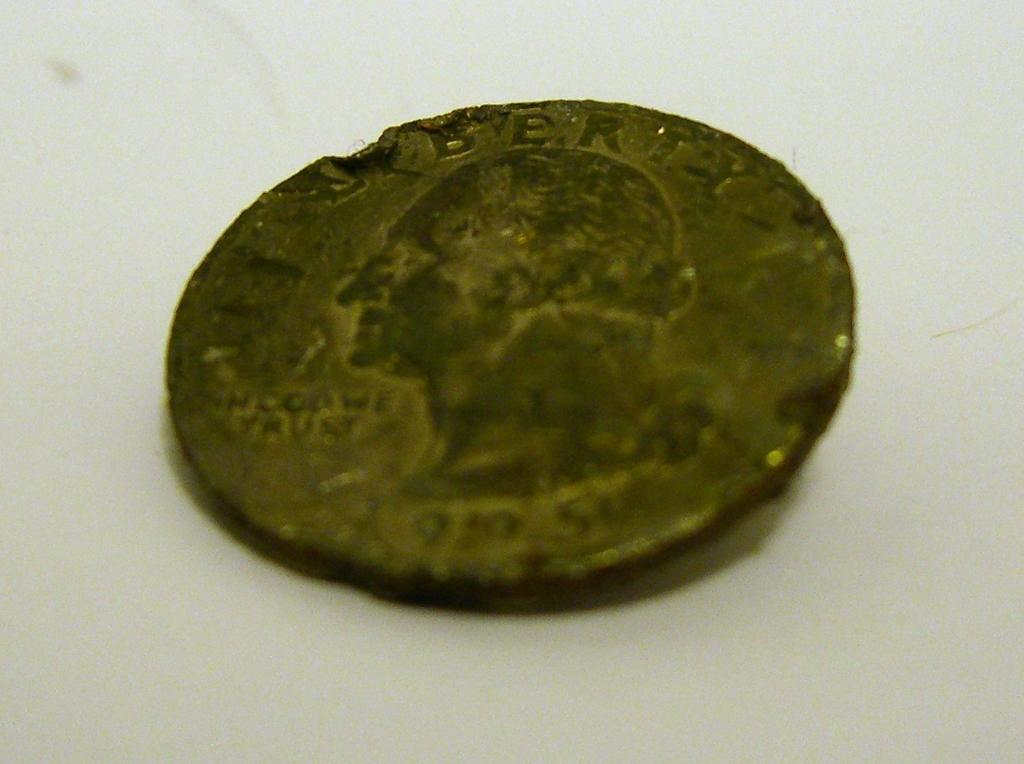Provide a one-sentence caption for the provided image. A tarnished quarter with the "i" in liberty missing from the top. 